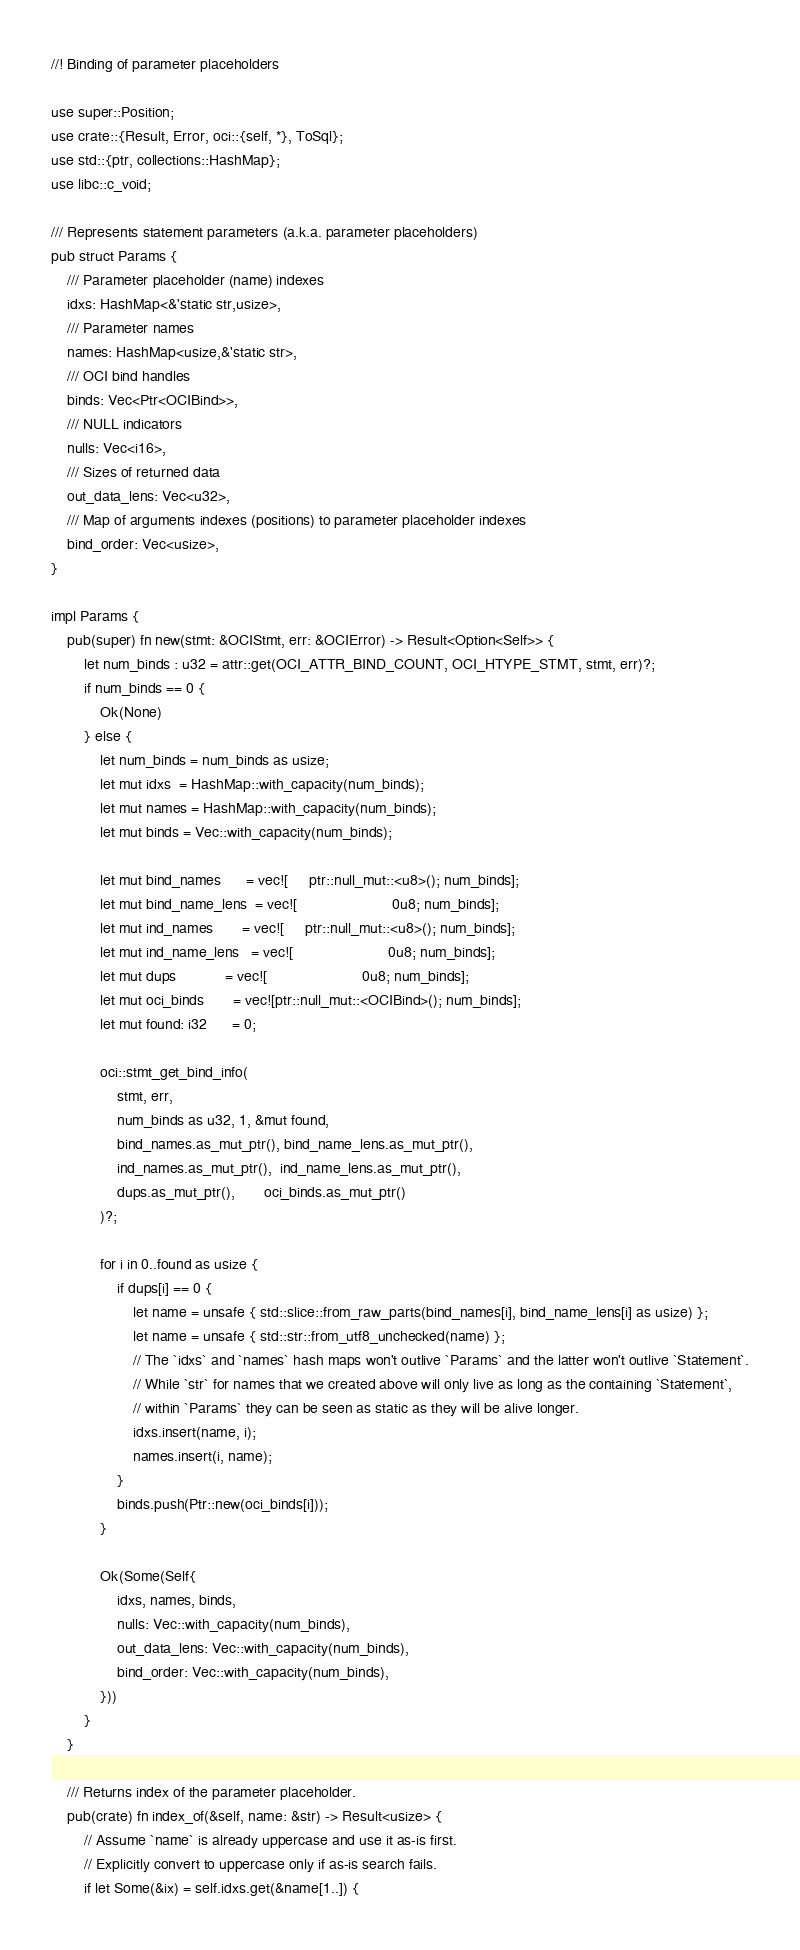Convert code to text. <code><loc_0><loc_0><loc_500><loc_500><_Rust_>//! Binding of parameter placeholders

use super::Position;
use crate::{Result, Error, oci::{self, *}, ToSql};
use std::{ptr, collections::HashMap};
use libc::c_void;

/// Represents statement parameters (a.k.a. parameter placeholders)
pub struct Params {
    /// Parameter placeholder (name) indexes
    idxs: HashMap<&'static str,usize>,
    /// Parameter names
    names: HashMap<usize,&'static str>,
    /// OCI bind handles
    binds: Vec<Ptr<OCIBind>>,
    /// NULL indicators
    nulls: Vec<i16>,
    /// Sizes of returned data
    out_data_lens: Vec<u32>,
    /// Map of arguments indexes (positions) to parameter placeholder indexes
    bind_order: Vec<usize>,
}

impl Params {
    pub(super) fn new(stmt: &OCIStmt, err: &OCIError) -> Result<Option<Self>> {
        let num_binds : u32 = attr::get(OCI_ATTR_BIND_COUNT, OCI_HTYPE_STMT, stmt, err)?;
        if num_binds == 0 {
            Ok(None)
        } else {
            let num_binds = num_binds as usize;
            let mut idxs  = HashMap::with_capacity(num_binds);
            let mut names = HashMap::with_capacity(num_binds);
            let mut binds = Vec::with_capacity(num_binds);

            let mut bind_names      = vec![     ptr::null_mut::<u8>(); num_binds];
            let mut bind_name_lens  = vec![                       0u8; num_binds];
            let mut ind_names       = vec![     ptr::null_mut::<u8>(); num_binds];
            let mut ind_name_lens   = vec![                       0u8; num_binds];
            let mut dups            = vec![                       0u8; num_binds];
            let mut oci_binds       = vec![ptr::null_mut::<OCIBind>(); num_binds];
            let mut found: i32      = 0;

            oci::stmt_get_bind_info(
                stmt, err,
                num_binds as u32, 1, &mut found,
                bind_names.as_mut_ptr(), bind_name_lens.as_mut_ptr(),
                ind_names.as_mut_ptr(),  ind_name_lens.as_mut_ptr(),
                dups.as_mut_ptr(),       oci_binds.as_mut_ptr()
            )?;

            for i in 0..found as usize {
                if dups[i] == 0 {
                    let name = unsafe { std::slice::from_raw_parts(bind_names[i], bind_name_lens[i] as usize) };
                    let name = unsafe { std::str::from_utf8_unchecked(name) };
                    // The `idxs` and `names` hash maps won't outlive `Params` and the latter won't outlive `Statement`.
                    // While `str` for names that we created above will only live as long as the containing `Statement`,
                    // within `Params` they can be seen as static as they will be alive longer.
                    idxs.insert(name, i);
                    names.insert(i, name);
                }
                binds.push(Ptr::new(oci_binds[i]));
            }

            Ok(Some(Self{
                idxs, names, binds,
                nulls: Vec::with_capacity(num_binds),
                out_data_lens: Vec::with_capacity(num_binds),
                bind_order: Vec::with_capacity(num_binds),
            }))
        }
    }

    /// Returns index of the parameter placeholder.
    pub(crate) fn index_of(&self, name: &str) -> Result<usize> {
        // Assume `name` is already uppercase and use it as-is first.
        // Explicitly convert to uppercase only if as-is search fails.
        if let Some(&ix) = self.idxs.get(&name[1..]) {</code> 